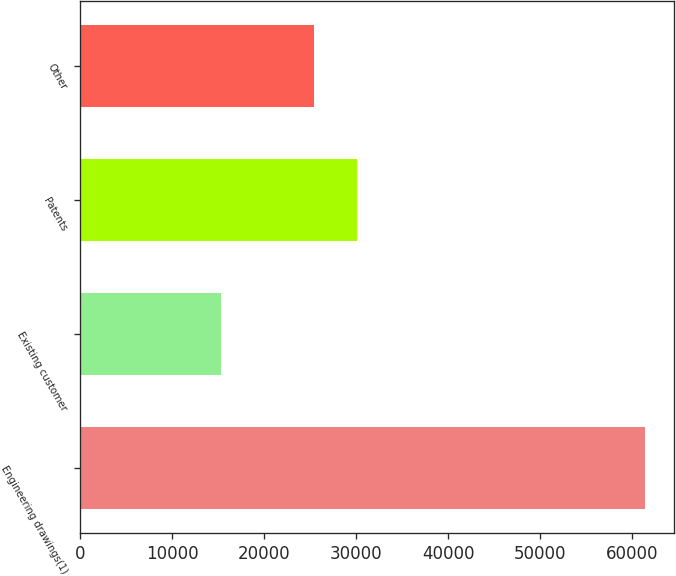<chart> <loc_0><loc_0><loc_500><loc_500><bar_chart><fcel>Engineering drawings(1)<fcel>Existing customer<fcel>Patents<fcel>Other<nl><fcel>61401<fcel>15241<fcel>30054<fcel>25438<nl></chart> 